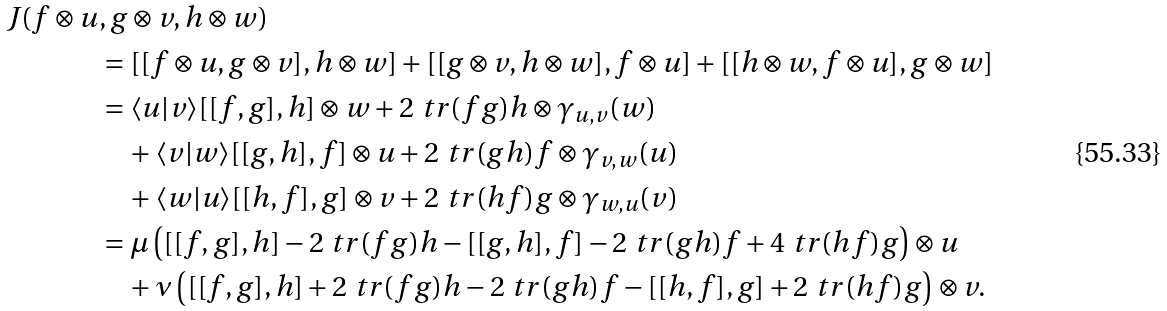Convert formula to latex. <formula><loc_0><loc_0><loc_500><loc_500>J ( f \otimes u & , g \otimes v , h \otimes w ) \\ & = [ [ f \otimes u , g \otimes v ] , h \otimes w ] + [ [ g \otimes v , h \otimes w ] , f \otimes u ] + [ [ h \otimes w , f \otimes u ] , g \otimes w ] \\ & = \langle u | v \rangle [ [ f , g ] , h ] \otimes w + 2 \ t r ( f g ) h \otimes \gamma _ { u , v } ( w ) \\ & \quad + \langle v | w \rangle [ [ g , h ] , f ] \otimes u + 2 \ t r ( g h ) f \otimes \gamma _ { v , w } ( u ) \\ & \quad + \langle w | u \rangle [ [ h , f ] , g ] \otimes v + 2 \ t r ( h f ) g \otimes \gamma _ { w , u } ( v ) \\ & = \mu \left ( [ [ f , g ] , h ] - 2 \ t r ( f g ) h - [ [ g , h ] , f ] - 2 \ t r ( g h ) f + 4 \ t r ( h f ) g \right ) \otimes u \\ & \quad + \nu \left ( [ [ f , g ] , h ] + 2 \ t r ( f g ) h - 2 \ t r ( g h ) f - [ [ h , f ] , g ] + 2 \ t r ( h f ) g \right ) \otimes v .</formula> 